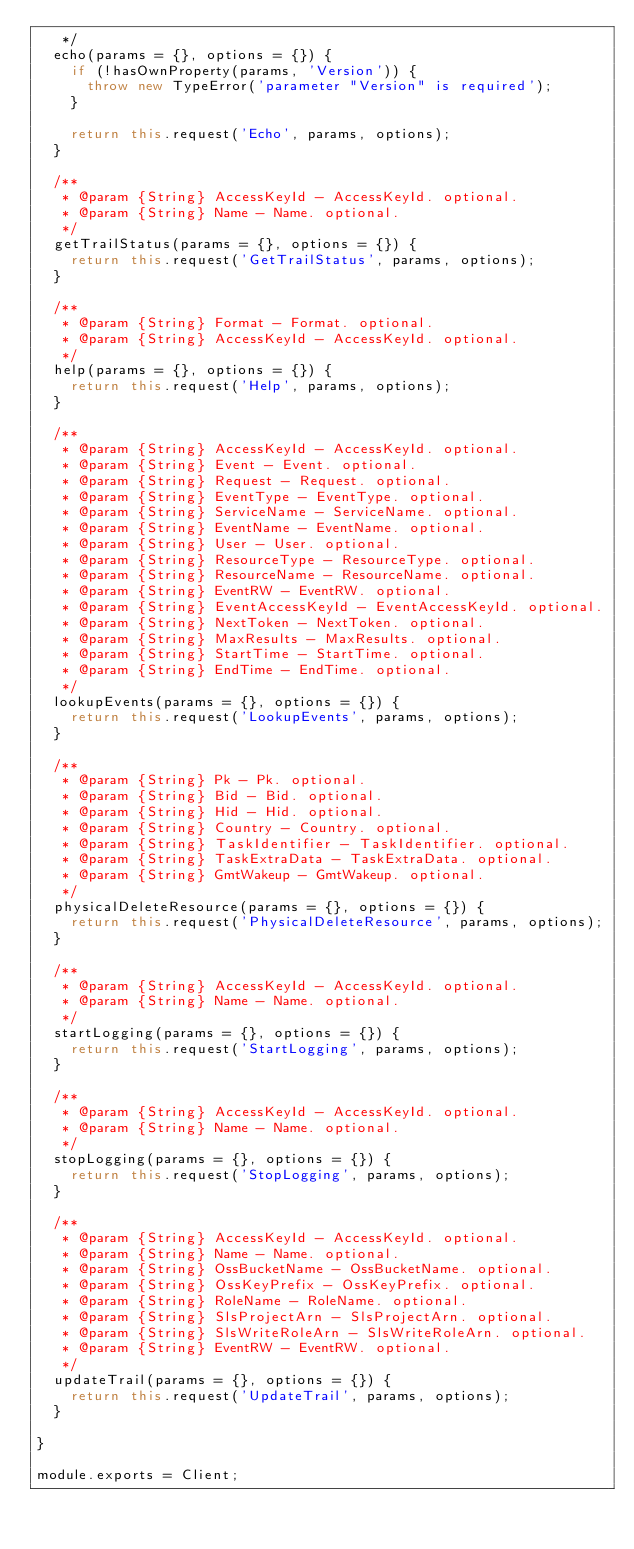<code> <loc_0><loc_0><loc_500><loc_500><_JavaScript_>   */
  echo(params = {}, options = {}) {
    if (!hasOwnProperty(params, 'Version')) {
      throw new TypeError('parameter "Version" is required');
    }

    return this.request('Echo', params, options);
  }

  /**
   * @param {String} AccessKeyId - AccessKeyId. optional.
   * @param {String} Name - Name. optional.
   */
  getTrailStatus(params = {}, options = {}) {
    return this.request('GetTrailStatus', params, options);
  }

  /**
   * @param {String} Format - Format. optional.
   * @param {String} AccessKeyId - AccessKeyId. optional.
   */
  help(params = {}, options = {}) {
    return this.request('Help', params, options);
  }

  /**
   * @param {String} AccessKeyId - AccessKeyId. optional.
   * @param {String} Event - Event. optional.
   * @param {String} Request - Request. optional.
   * @param {String} EventType - EventType. optional.
   * @param {String} ServiceName - ServiceName. optional.
   * @param {String} EventName - EventName. optional.
   * @param {String} User - User. optional.
   * @param {String} ResourceType - ResourceType. optional.
   * @param {String} ResourceName - ResourceName. optional.
   * @param {String} EventRW - EventRW. optional.
   * @param {String} EventAccessKeyId - EventAccessKeyId. optional.
   * @param {String} NextToken - NextToken. optional.
   * @param {String} MaxResults - MaxResults. optional.
   * @param {String} StartTime - StartTime. optional.
   * @param {String} EndTime - EndTime. optional.
   */
  lookupEvents(params = {}, options = {}) {
    return this.request('LookupEvents', params, options);
  }

  /**
   * @param {String} Pk - Pk. optional.
   * @param {String} Bid - Bid. optional.
   * @param {String} Hid - Hid. optional.
   * @param {String} Country - Country. optional.
   * @param {String} TaskIdentifier - TaskIdentifier. optional.
   * @param {String} TaskExtraData - TaskExtraData. optional.
   * @param {String} GmtWakeup - GmtWakeup. optional.
   */
  physicalDeleteResource(params = {}, options = {}) {
    return this.request('PhysicalDeleteResource', params, options);
  }

  /**
   * @param {String} AccessKeyId - AccessKeyId. optional.
   * @param {String} Name - Name. optional.
   */
  startLogging(params = {}, options = {}) {
    return this.request('StartLogging', params, options);
  }

  /**
   * @param {String} AccessKeyId - AccessKeyId. optional.
   * @param {String} Name - Name. optional.
   */
  stopLogging(params = {}, options = {}) {
    return this.request('StopLogging', params, options);
  }

  /**
   * @param {String} AccessKeyId - AccessKeyId. optional.
   * @param {String} Name - Name. optional.
   * @param {String} OssBucketName - OssBucketName. optional.
   * @param {String} OssKeyPrefix - OssKeyPrefix. optional.
   * @param {String} RoleName - RoleName. optional.
   * @param {String} SlsProjectArn - SlsProjectArn. optional.
   * @param {String} SlsWriteRoleArn - SlsWriteRoleArn. optional.
   * @param {String} EventRW - EventRW. optional.
   */
  updateTrail(params = {}, options = {}) {
    return this.request('UpdateTrail', params, options);
  }

}

module.exports = Client;
</code> 